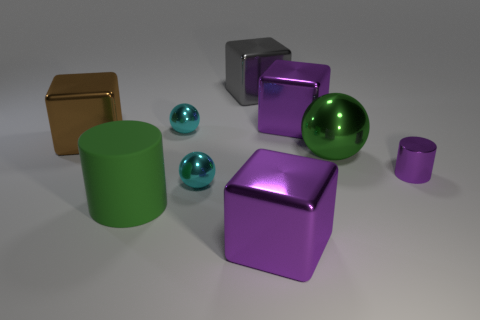Add 1 big balls. How many objects exist? 10 Subtract all gray cubes. How many cubes are left? 3 Subtract all big gray metal cubes. How many cubes are left? 3 Subtract all red blocks. Subtract all gray spheres. How many blocks are left? 4 Subtract all cubes. How many objects are left? 5 Subtract all shiny objects. Subtract all big cyan cylinders. How many objects are left? 1 Add 1 cyan metal spheres. How many cyan metal spheres are left? 3 Add 5 tiny purple shiny cylinders. How many tiny purple shiny cylinders exist? 6 Subtract 0 red cylinders. How many objects are left? 9 